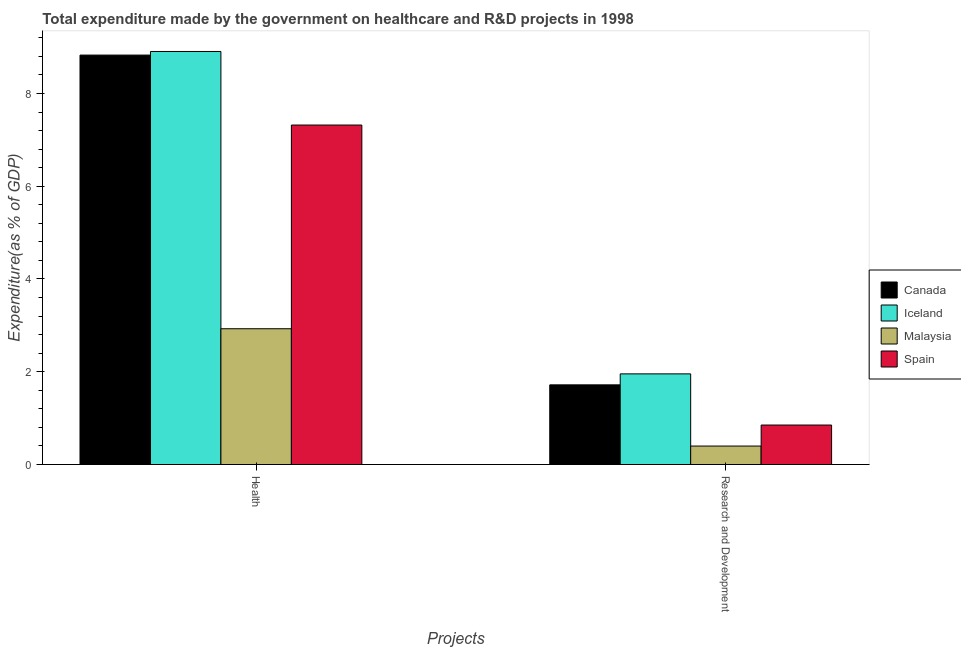How many different coloured bars are there?
Provide a short and direct response. 4. How many bars are there on the 2nd tick from the left?
Provide a short and direct response. 4. What is the label of the 2nd group of bars from the left?
Make the answer very short. Research and Development. What is the expenditure in r&d in Canada?
Your answer should be very brief. 1.72. Across all countries, what is the maximum expenditure in healthcare?
Your answer should be very brief. 8.91. Across all countries, what is the minimum expenditure in r&d?
Provide a succinct answer. 0.4. In which country was the expenditure in r&d minimum?
Make the answer very short. Malaysia. What is the total expenditure in healthcare in the graph?
Keep it short and to the point. 27.98. What is the difference between the expenditure in healthcare in Iceland and that in Spain?
Offer a very short reply. 1.59. What is the difference between the expenditure in healthcare in Spain and the expenditure in r&d in Canada?
Ensure brevity in your answer.  5.6. What is the average expenditure in r&d per country?
Your answer should be compact. 1.23. What is the difference between the expenditure in healthcare and expenditure in r&d in Spain?
Your response must be concise. 6.47. In how many countries, is the expenditure in healthcare greater than 2.4 %?
Your answer should be compact. 4. What is the ratio of the expenditure in r&d in Iceland to that in Spain?
Give a very brief answer. 2.3. What does the 2nd bar from the left in Research and Development represents?
Offer a very short reply. Iceland. What does the 2nd bar from the right in Research and Development represents?
Keep it short and to the point. Malaysia. Are all the bars in the graph horizontal?
Offer a terse response. No. Does the graph contain any zero values?
Give a very brief answer. No. Does the graph contain grids?
Provide a short and direct response. No. What is the title of the graph?
Your answer should be very brief. Total expenditure made by the government on healthcare and R&D projects in 1998. Does "South Asia" appear as one of the legend labels in the graph?
Your answer should be compact. No. What is the label or title of the X-axis?
Your answer should be compact. Projects. What is the label or title of the Y-axis?
Offer a terse response. Expenditure(as % of GDP). What is the Expenditure(as % of GDP) of Canada in Health?
Your answer should be compact. 8.83. What is the Expenditure(as % of GDP) in Iceland in Health?
Make the answer very short. 8.91. What is the Expenditure(as % of GDP) of Malaysia in Health?
Offer a terse response. 2.93. What is the Expenditure(as % of GDP) in Spain in Health?
Provide a short and direct response. 7.32. What is the Expenditure(as % of GDP) of Canada in Research and Development?
Your answer should be compact. 1.72. What is the Expenditure(as % of GDP) of Iceland in Research and Development?
Offer a very short reply. 1.95. What is the Expenditure(as % of GDP) of Malaysia in Research and Development?
Provide a short and direct response. 0.4. What is the Expenditure(as % of GDP) in Spain in Research and Development?
Ensure brevity in your answer.  0.85. Across all Projects, what is the maximum Expenditure(as % of GDP) of Canada?
Your response must be concise. 8.83. Across all Projects, what is the maximum Expenditure(as % of GDP) in Iceland?
Keep it short and to the point. 8.91. Across all Projects, what is the maximum Expenditure(as % of GDP) of Malaysia?
Make the answer very short. 2.93. Across all Projects, what is the maximum Expenditure(as % of GDP) in Spain?
Offer a very short reply. 7.32. Across all Projects, what is the minimum Expenditure(as % of GDP) of Canada?
Your response must be concise. 1.72. Across all Projects, what is the minimum Expenditure(as % of GDP) of Iceland?
Give a very brief answer. 1.95. Across all Projects, what is the minimum Expenditure(as % of GDP) in Malaysia?
Provide a succinct answer. 0.4. Across all Projects, what is the minimum Expenditure(as % of GDP) of Spain?
Your response must be concise. 0.85. What is the total Expenditure(as % of GDP) of Canada in the graph?
Your response must be concise. 10.54. What is the total Expenditure(as % of GDP) of Iceland in the graph?
Provide a short and direct response. 10.86. What is the total Expenditure(as % of GDP) of Malaysia in the graph?
Offer a very short reply. 3.33. What is the total Expenditure(as % of GDP) in Spain in the graph?
Provide a short and direct response. 8.17. What is the difference between the Expenditure(as % of GDP) in Canada in Health and that in Research and Development?
Make the answer very short. 7.11. What is the difference between the Expenditure(as % of GDP) in Iceland in Health and that in Research and Development?
Keep it short and to the point. 6.95. What is the difference between the Expenditure(as % of GDP) of Malaysia in Health and that in Research and Development?
Offer a terse response. 2.53. What is the difference between the Expenditure(as % of GDP) in Spain in Health and that in Research and Development?
Your response must be concise. 6.47. What is the difference between the Expenditure(as % of GDP) in Canada in Health and the Expenditure(as % of GDP) in Iceland in Research and Development?
Give a very brief answer. 6.87. What is the difference between the Expenditure(as % of GDP) of Canada in Health and the Expenditure(as % of GDP) of Malaysia in Research and Development?
Offer a very short reply. 8.43. What is the difference between the Expenditure(as % of GDP) in Canada in Health and the Expenditure(as % of GDP) in Spain in Research and Development?
Offer a terse response. 7.98. What is the difference between the Expenditure(as % of GDP) in Iceland in Health and the Expenditure(as % of GDP) in Malaysia in Research and Development?
Provide a short and direct response. 8.51. What is the difference between the Expenditure(as % of GDP) of Iceland in Health and the Expenditure(as % of GDP) of Spain in Research and Development?
Keep it short and to the point. 8.05. What is the difference between the Expenditure(as % of GDP) in Malaysia in Health and the Expenditure(as % of GDP) in Spain in Research and Development?
Keep it short and to the point. 2.08. What is the average Expenditure(as % of GDP) of Canada per Projects?
Your response must be concise. 5.27. What is the average Expenditure(as % of GDP) of Iceland per Projects?
Your response must be concise. 5.43. What is the average Expenditure(as % of GDP) of Malaysia per Projects?
Offer a terse response. 1.66. What is the average Expenditure(as % of GDP) of Spain per Projects?
Ensure brevity in your answer.  4.09. What is the difference between the Expenditure(as % of GDP) of Canada and Expenditure(as % of GDP) of Iceland in Health?
Offer a very short reply. -0.08. What is the difference between the Expenditure(as % of GDP) in Canada and Expenditure(as % of GDP) in Malaysia in Health?
Provide a short and direct response. 5.9. What is the difference between the Expenditure(as % of GDP) of Canada and Expenditure(as % of GDP) of Spain in Health?
Ensure brevity in your answer.  1.51. What is the difference between the Expenditure(as % of GDP) in Iceland and Expenditure(as % of GDP) in Malaysia in Health?
Offer a terse response. 5.98. What is the difference between the Expenditure(as % of GDP) of Iceland and Expenditure(as % of GDP) of Spain in Health?
Ensure brevity in your answer.  1.59. What is the difference between the Expenditure(as % of GDP) in Malaysia and Expenditure(as % of GDP) in Spain in Health?
Provide a short and direct response. -4.39. What is the difference between the Expenditure(as % of GDP) of Canada and Expenditure(as % of GDP) of Iceland in Research and Development?
Provide a short and direct response. -0.24. What is the difference between the Expenditure(as % of GDP) in Canada and Expenditure(as % of GDP) in Malaysia in Research and Development?
Keep it short and to the point. 1.32. What is the difference between the Expenditure(as % of GDP) in Canada and Expenditure(as % of GDP) in Spain in Research and Development?
Provide a short and direct response. 0.87. What is the difference between the Expenditure(as % of GDP) in Iceland and Expenditure(as % of GDP) in Malaysia in Research and Development?
Offer a very short reply. 1.56. What is the difference between the Expenditure(as % of GDP) of Iceland and Expenditure(as % of GDP) of Spain in Research and Development?
Provide a short and direct response. 1.1. What is the difference between the Expenditure(as % of GDP) of Malaysia and Expenditure(as % of GDP) of Spain in Research and Development?
Your answer should be very brief. -0.45. What is the ratio of the Expenditure(as % of GDP) of Canada in Health to that in Research and Development?
Your response must be concise. 5.14. What is the ratio of the Expenditure(as % of GDP) in Iceland in Health to that in Research and Development?
Keep it short and to the point. 4.56. What is the ratio of the Expenditure(as % of GDP) of Malaysia in Health to that in Research and Development?
Keep it short and to the point. 7.36. What is the ratio of the Expenditure(as % of GDP) in Spain in Health to that in Research and Development?
Your answer should be very brief. 8.6. What is the difference between the highest and the second highest Expenditure(as % of GDP) in Canada?
Make the answer very short. 7.11. What is the difference between the highest and the second highest Expenditure(as % of GDP) in Iceland?
Give a very brief answer. 6.95. What is the difference between the highest and the second highest Expenditure(as % of GDP) in Malaysia?
Make the answer very short. 2.53. What is the difference between the highest and the second highest Expenditure(as % of GDP) of Spain?
Offer a terse response. 6.47. What is the difference between the highest and the lowest Expenditure(as % of GDP) in Canada?
Provide a succinct answer. 7.11. What is the difference between the highest and the lowest Expenditure(as % of GDP) in Iceland?
Your answer should be very brief. 6.95. What is the difference between the highest and the lowest Expenditure(as % of GDP) of Malaysia?
Offer a terse response. 2.53. What is the difference between the highest and the lowest Expenditure(as % of GDP) of Spain?
Your answer should be very brief. 6.47. 